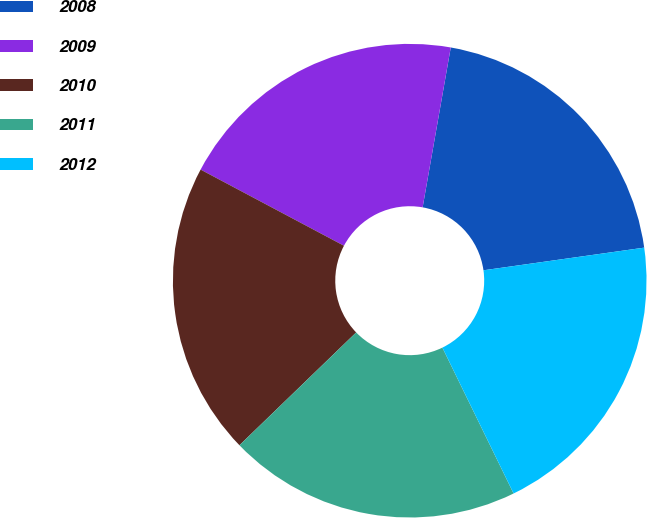Convert chart to OTSL. <chart><loc_0><loc_0><loc_500><loc_500><pie_chart><fcel>2008<fcel>2009<fcel>2010<fcel>2011<fcel>2012<nl><fcel>20.0%<fcel>20.0%<fcel>20.0%<fcel>20.0%<fcel>20.0%<nl></chart> 